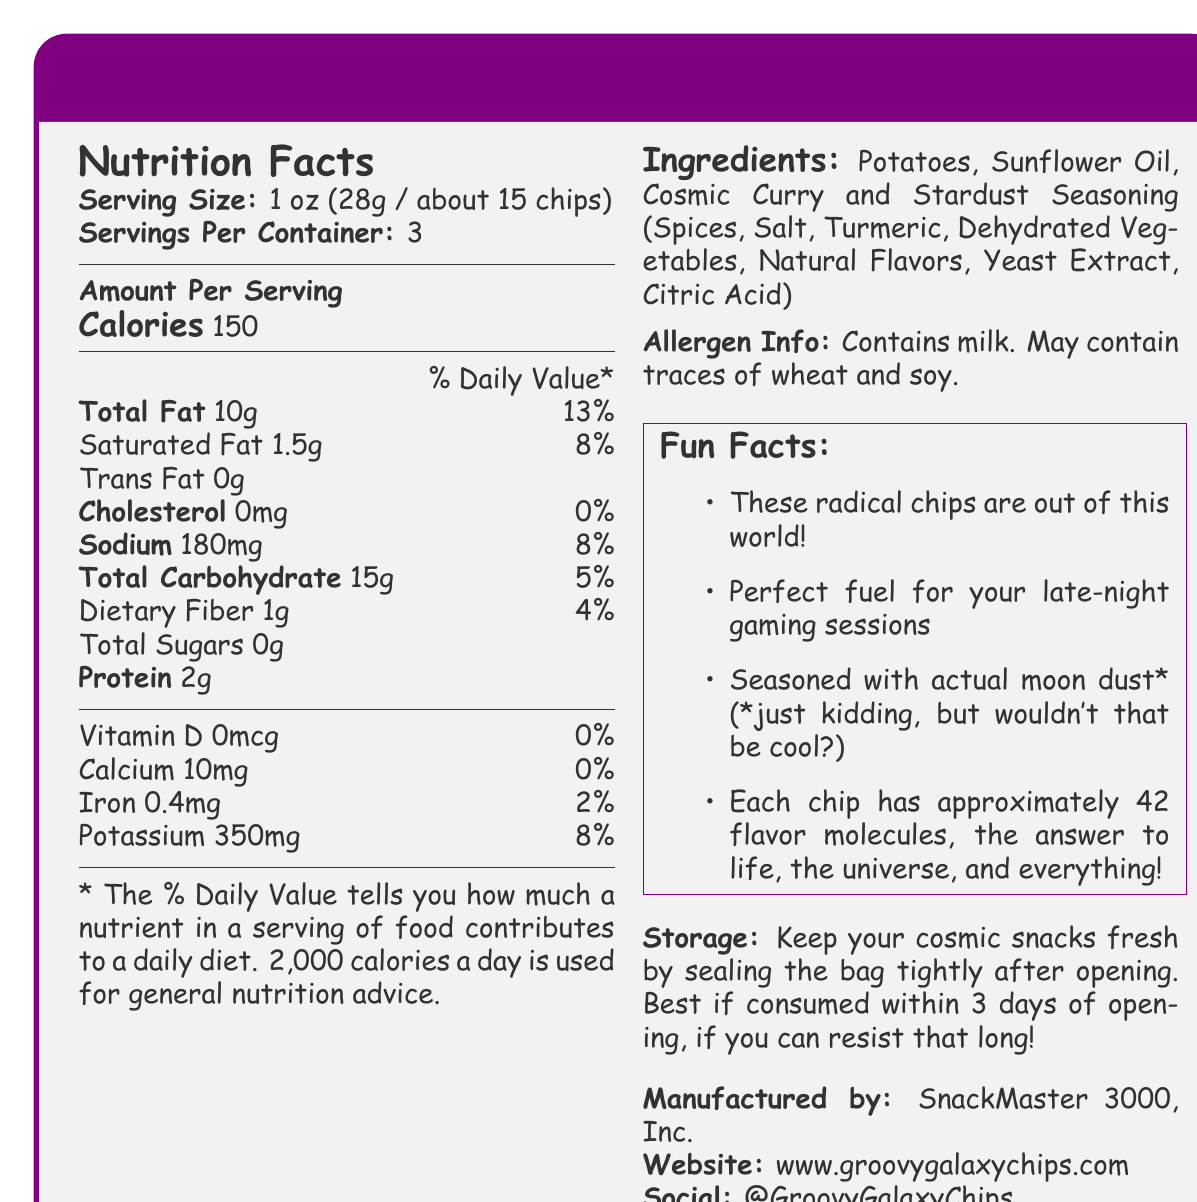what is the serving size of Groovy Galaxy Potato Chips? The document explicitly states that the serving size is 1 oz (28g / about 15 chips).
Answer: 1 oz (28g / about 15 chips) how many calories are in one serving? The document lists the calories per serving as 150.
Answer: 150 how many servings are in each container? The document mentions that there are 3 servings per container.
Answer: 3 what is the total amount of fat per serving? The document specifies that the total fat per serving is 10g.
Answer: 10g how many grams of protein are in one serving? The document states that there are 2g of protein per serving.
Answer: 2g what is the percentage daily value of sodium per serving? The document says the sodium content per serving is 180mg, which is 8% of the daily value.
Answer: 8% does the product contain any allergens? The document indicates that the product contains milk and may contain traces of wheat and soy.
Answer: Yes what are the primary ingredients in the Cosmic Curry and Stardust seasoning? The document lists these ingredients as part of the Cosmic Curry and Stardust seasoning.
Answer: Spices, Salt, Turmeric, Dehydrated Vegetables, Natural Flavors, Yeast Extract, Citric Acid which of the following is a Fun Fact mentioned in the document? 
  A. These chips are made with organic potatoes.
  B. Each chip contains the essence of a supernova.
  C. Perfect fuel for your late-night gaming sessions.
  D. Contains a secret ingredient found only on Mars. The document lists "Perfect fuel for your late-night gaming sessions" as one of the Fun Facts.
Answer: C what is the correct daily value for dietary fiber in one serving? 
  1. 1%
  2. 2%
  3. 4%
  4. 8% The document states that dietary fiber per serving is 1g, which is 4% of the daily value.
Answer: 3 are these chips seasoned with actual moon dust? The document humorously states that the chips are not actually seasoned with moon dust.
Answer: No how should you store the chips to keep them fresh? The document provides storage instructions to seal the bag tightly and recommends consuming within 3 days of opening.
Answer: Seal the bag tightly after opening and consume within 3 days. who manufactures Groovy Galaxy Potato Chips? The document lists SnackMaster 3000, Inc. as the manufacturer.
Answer: SnackMaster 3000, Inc. what is the manufacturer's website? The document provides the website www.groovygalaxychips.com.
Answer: www.groovygalaxychips.com how much calcium is in one serving of the chips? The document states that there are 10mg of calcium in one serving.
Answer: 10mg does the product contain any cholesterol? The document indicates that the product contains 0mg of cholesterol.
Answer: No how many flavor molecules does each chip have? The document humorously claims each chip has approximately 42 flavor molecules.
Answer: 42 summarize the main idea of the document The document includes vital nutritional details, quirky fun facts, and practical information such as storage guidelines and allergen warnings for Groovy Galaxy Potato Chips.
Answer: The document provides detailed nutritional information, ingredient list, allergen information, storage instructions, and fun facts about Groovy Galaxy Potato Chips - Cosmic Curry and Stardust flavor. It also specifies serving size, calorie content, and daily values for various nutrients. how many calories are burned in a 30-minute workout after eating one serving of the chips? The document does not provide details on calorie expenditure during workouts, thus the question cannot be answered based on the provided information.
Answer: Not enough information 